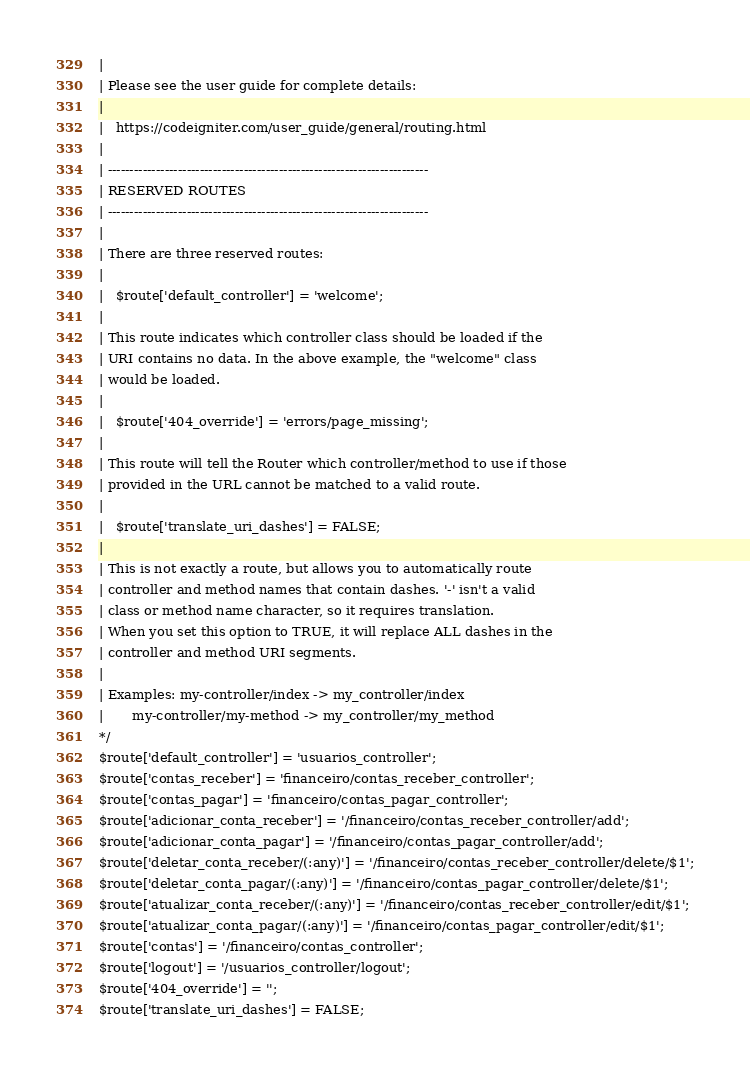Convert code to text. <code><loc_0><loc_0><loc_500><loc_500><_PHP_>|
| Please see the user guide for complete details:
|
|	https://codeigniter.com/user_guide/general/routing.html
|
| -------------------------------------------------------------------------
| RESERVED ROUTES
| -------------------------------------------------------------------------
|
| There are three reserved routes:
|
|	$route['default_controller'] = 'welcome';
|
| This route indicates which controller class should be loaded if the
| URI contains no data. In the above example, the "welcome" class
| would be loaded.
|
|	$route['404_override'] = 'errors/page_missing';
|
| This route will tell the Router which controller/method to use if those
| provided in the URL cannot be matched to a valid route.
|
|	$route['translate_uri_dashes'] = FALSE;
|
| This is not exactly a route, but allows you to automatically route
| controller and method names that contain dashes. '-' isn't a valid
| class or method name character, so it requires translation.
| When you set this option to TRUE, it will replace ALL dashes in the
| controller and method URI segments.
|
| Examples:	my-controller/index	-> my_controller/index
|		my-controller/my-method	-> my_controller/my_method
*/
$route['default_controller'] = 'usuarios_controller';
$route['contas_receber'] = 'financeiro/contas_receber_controller';
$route['contas_pagar'] = 'financeiro/contas_pagar_controller';
$route['adicionar_conta_receber'] = '/financeiro/contas_receber_controller/add';
$route['adicionar_conta_pagar'] = '/financeiro/contas_pagar_controller/add';
$route['deletar_conta_receber/(:any)'] = '/financeiro/contas_receber_controller/delete/$1';
$route['deletar_conta_pagar/(:any)'] = '/financeiro/contas_pagar_controller/delete/$1';
$route['atualizar_conta_receber/(:any)'] = '/financeiro/contas_receber_controller/edit/$1';
$route['atualizar_conta_pagar/(:any)'] = '/financeiro/contas_pagar_controller/edit/$1';
$route['contas'] = '/financeiro/contas_controller';
$route['logout'] = '/usuarios_controller/logout';
$route['404_override'] = '';
$route['translate_uri_dashes'] = FALSE;
</code> 